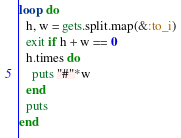Convert code to text. <code><loc_0><loc_0><loc_500><loc_500><_Ruby_>loop do
  h, w = gets.split.map(&:to_i)
  exit if h + w == 0
  h.times do
    puts "#"*w
  end
  puts
end</code> 